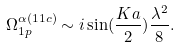<formula> <loc_0><loc_0><loc_500><loc_500>\Omega _ { 1 p } ^ { \alpha ( 1 1 c ) } \sim i \sin ( \frac { K a } { 2 } ) \frac { \lambda ^ { 2 } } { 8 } .</formula> 